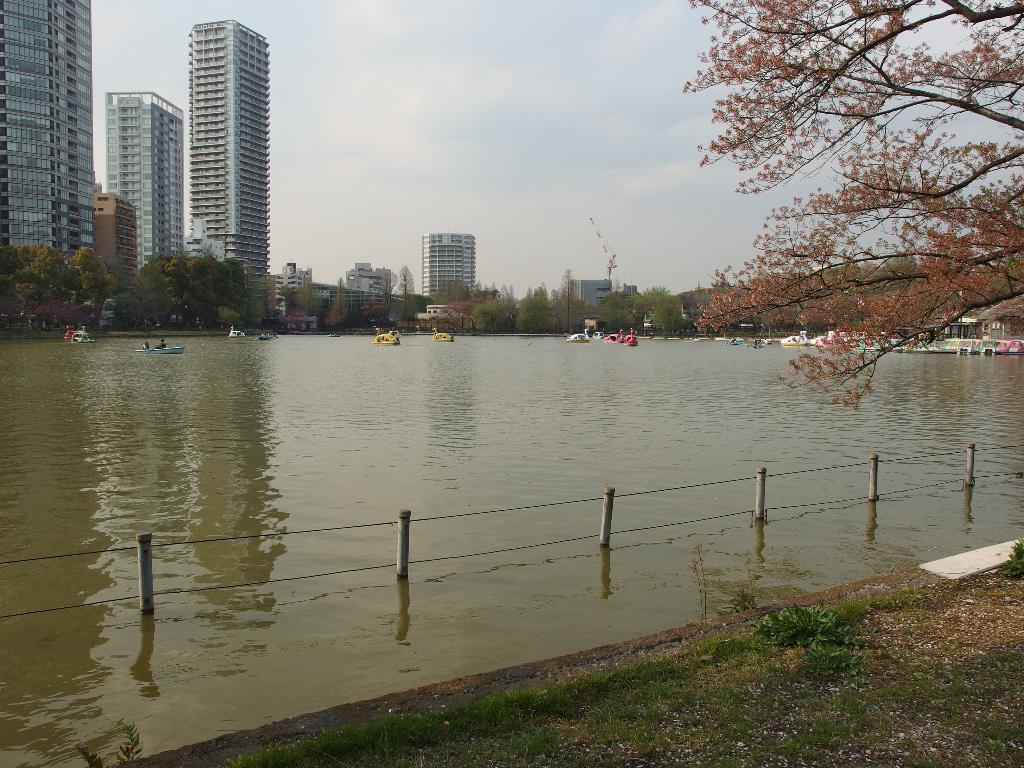What can be seen floating on the water in the image? There are boats on the water in the image. What type of vegetation is visible in the image? There is grass visible in the image. What structure can be seen separating the grassy area from another part of the image? There is a fence in the image. What type of plants are present in the image besides grass? There are trees in the image. What type of man-made structures can be seen in the image? There are buildings in the image. What is visible in the background of the image? The sky is visible in the background of the image. What type of flower is growing on the fence in the image? There are no flowers visible on the fence in the image. What type of thread is being used to hold the boats together in the image? There is no thread visible in the image, and the boats are not connected to each other. 